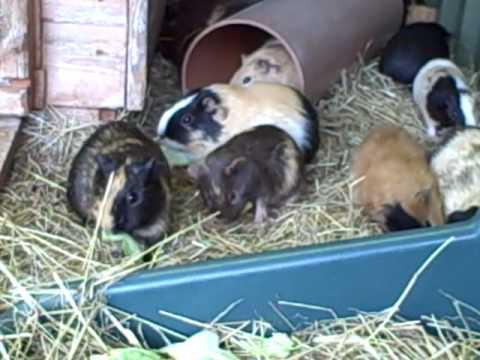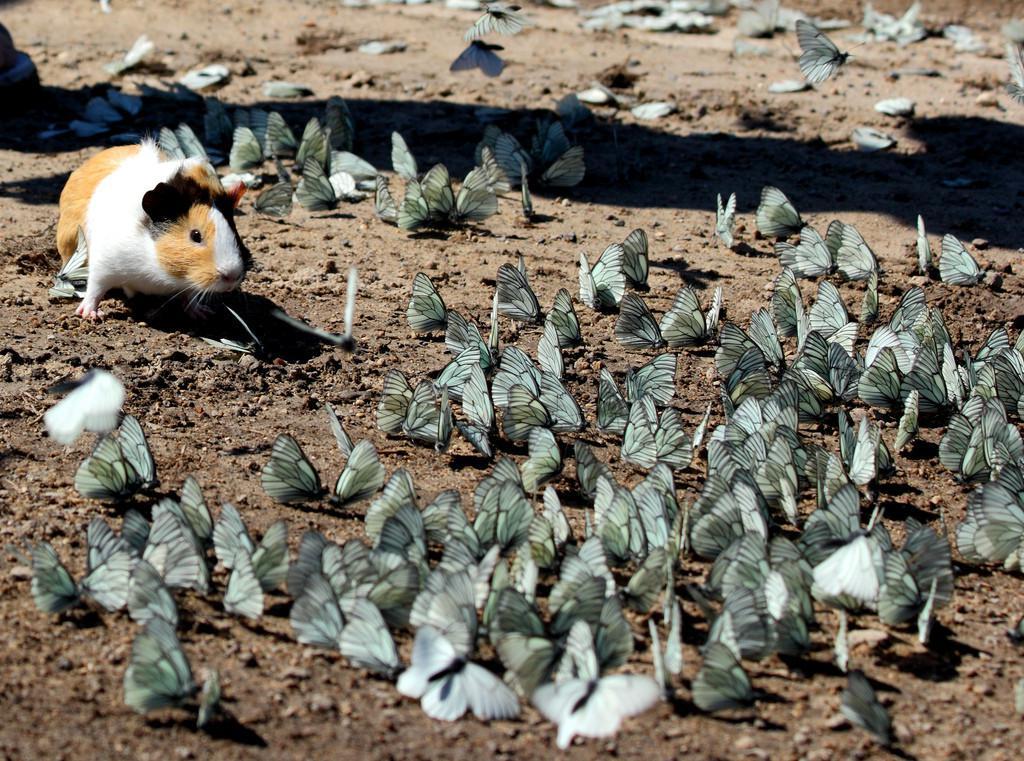The first image is the image on the left, the second image is the image on the right. For the images shown, is this caption "The animals in the image on the left are not in an enclosure." true? Answer yes or no. No. 